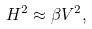Convert formula to latex. <formula><loc_0><loc_0><loc_500><loc_500>H ^ { 2 } \approx \beta V ^ { 2 } ,</formula> 